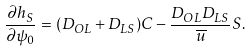<formula> <loc_0><loc_0><loc_500><loc_500>\frac { \partial h _ { S } } { \partial \psi _ { 0 } } = ( D _ { O L } + D _ { L S } ) C - \frac { D _ { O L } D _ { L S } } { \overline { u } } S .</formula> 